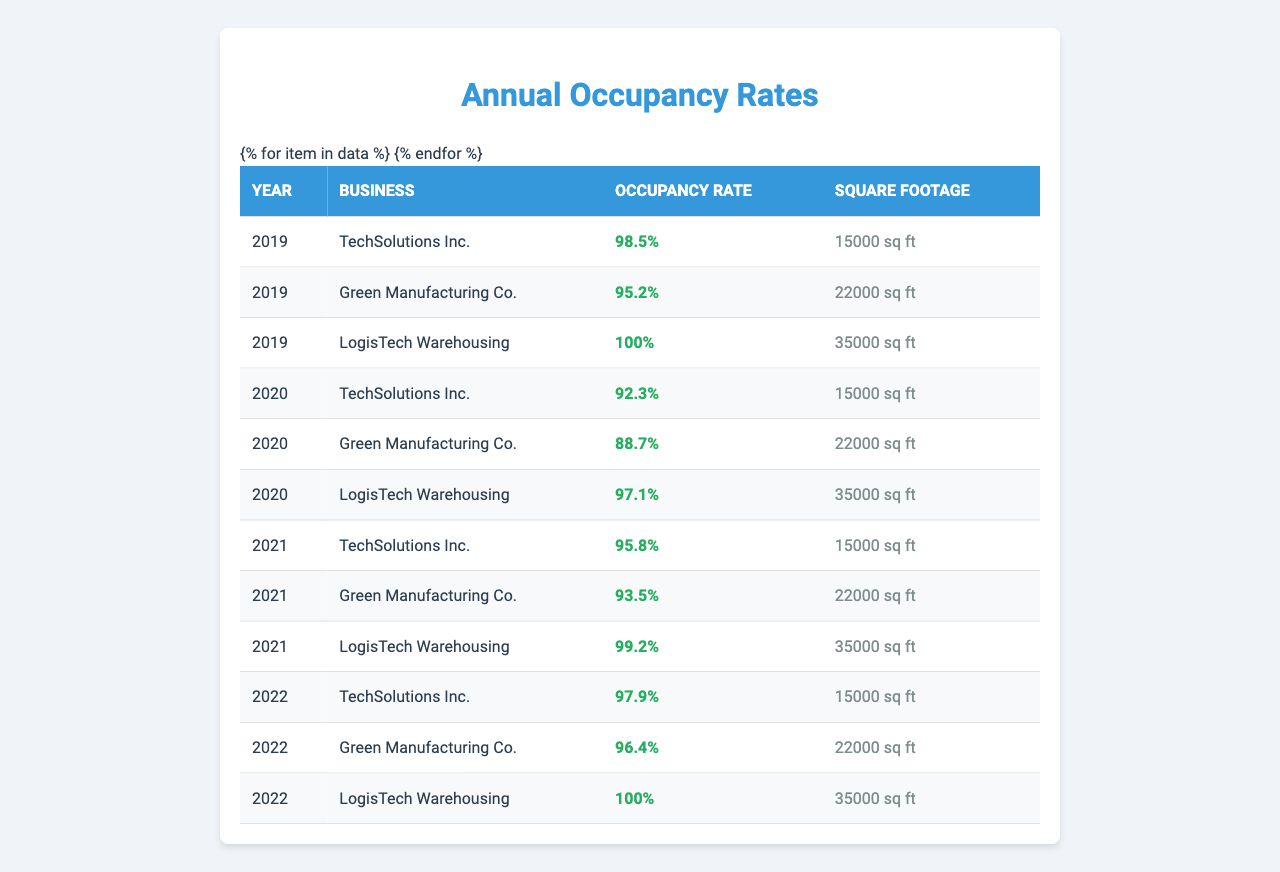What was the occupancy rate of Green Manufacturing Co. in 2020? The table shows that the occupancy rate for Green Manufacturing Co. in 2020 is 88.7%.
Answer: 88.7% Which business had the highest occupancy rate in 2019? Looking through the 2019 data, LogisTech Warehousing has an occupancy rate of 100%, which is the highest among all businesses for that year.
Answer: LogisTech Warehousing Calculate the average occupancy rate for TechSolutions Inc. from 2019 to 2022. The occupancy rates for TechSolutions Inc. from 2019 to 2022 are 98.5%, 92.3%, 95.8%, and 97.9%. The average is (98.5 + 92.3 + 95.8 + 97.9) / 4 = 96.375%.
Answer: 96.375% Did Green Manufacturing Co. improve its occupancy rate from 2020 to 2022? In 2020, Green Manufacturing Co. had an occupancy rate of 88.7%, and in 2022, it was 96.4%. Since 96.4% is greater than 88.7%, the occupancy rate improved.
Answer: Yes What is the total square footage occupied by LogisTech Warehousing over the four years? LogisTech Warehousing has a square footage of 35,000 sq ft for each year from 2019 to 2022. Hence, the total square footage is 35,000 * 4 = 140,000 sq ft.
Answer: 140,000 sq ft Is the occupancy rate of TechSolutions Inc. for 2021 higher than that of Green Manufacturing Co. for the same year? TechSolutions Inc. had an occupancy rate of 95.8% in 2021, while Green Manufacturing Co. had 93.5%. Since 95.8% is higher than 93.5%, TechSolutions Inc. has a higher rate.
Answer: Yes What was the percentage decrease in occupancy rate for Green Manufacturing Co. from 2019 to 2020? Green Manufacturing Co.'s occupancy rate decreased from 95.2% in 2019 to 88.7% in 2020. The decrease is calculated as (95.2 - 88.7) / 95.2 * 100 = 5.24%.
Answer: 5.24% Which year did TechSolutions Inc. have its lowest occupancy rate? The occupancy rates for TechSolutions Inc. across the years are 98.5% in 2019, 92.3% in 2020, 95.8% in 2021, and 97.9% in 2022. The lowest occupancy rate is 92.3% in 2020.
Answer: 2020 